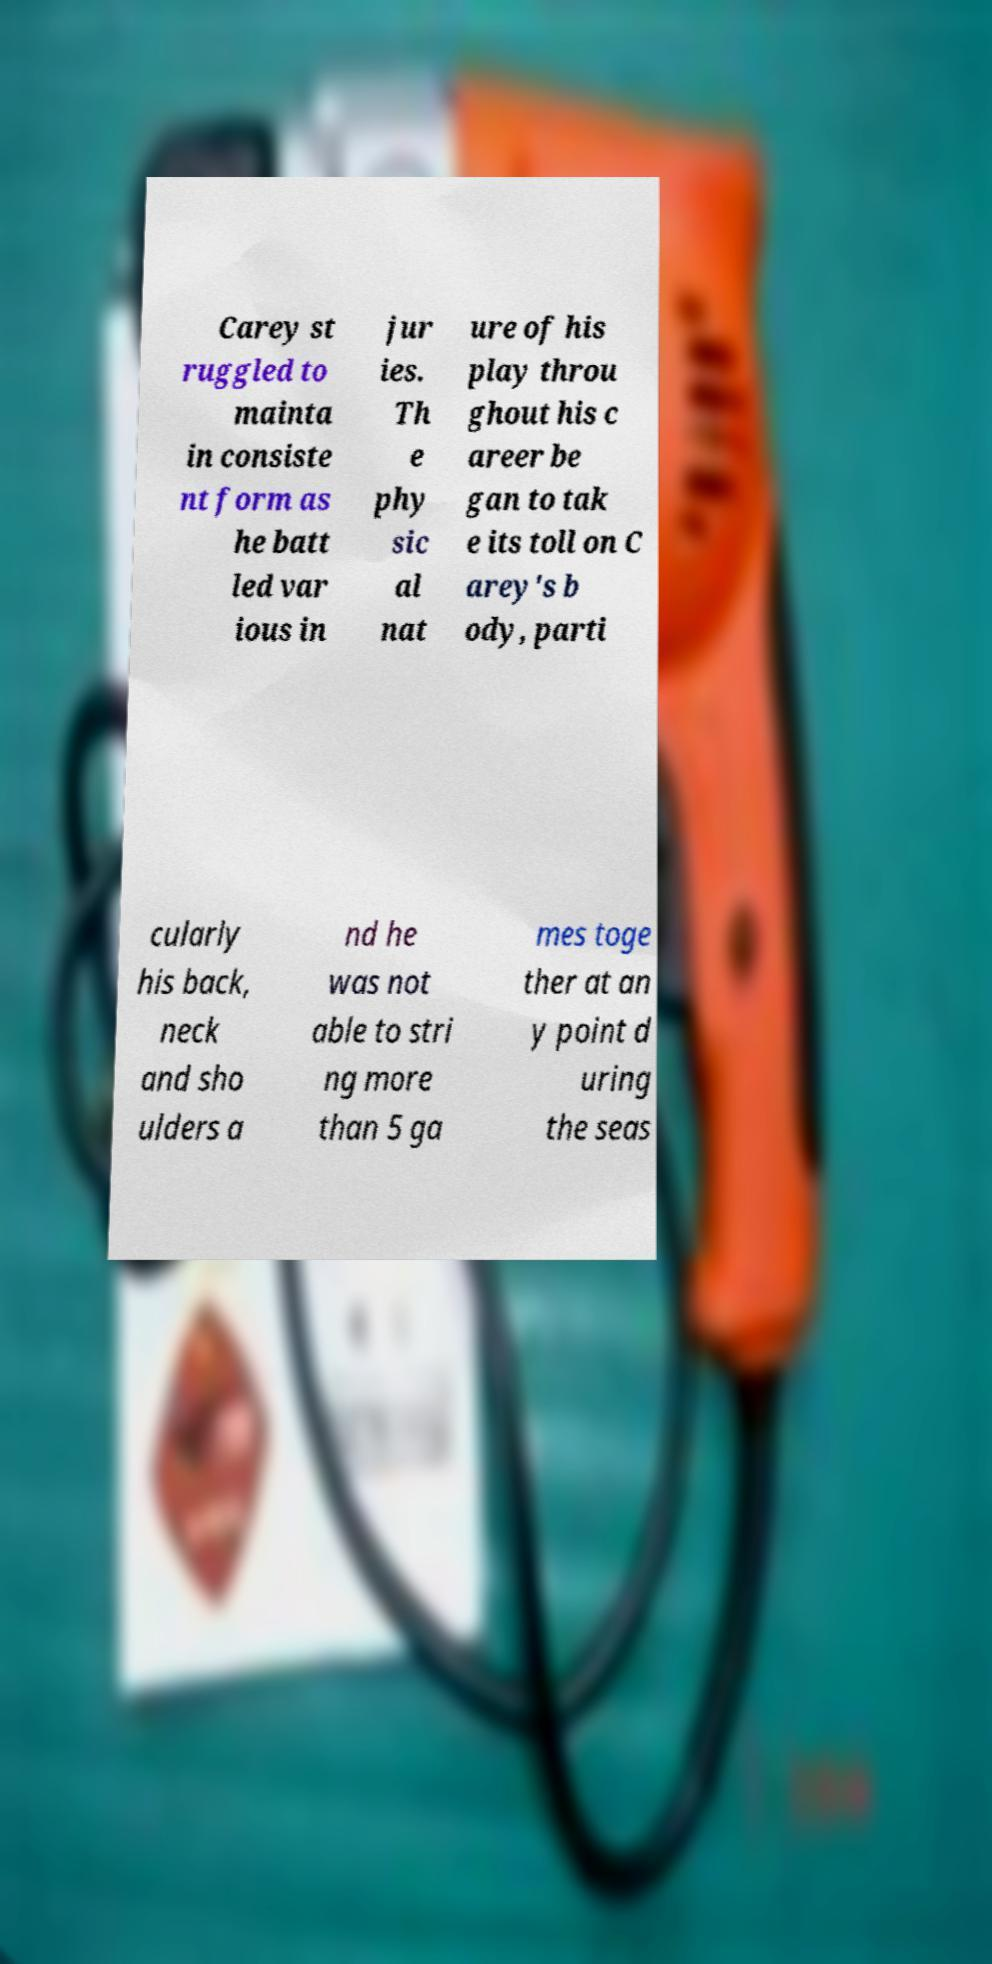Could you extract and type out the text from this image? Carey st ruggled to mainta in consiste nt form as he batt led var ious in jur ies. Th e phy sic al nat ure of his play throu ghout his c areer be gan to tak e its toll on C arey's b ody, parti cularly his back, neck and sho ulders a nd he was not able to stri ng more than 5 ga mes toge ther at an y point d uring the seas 